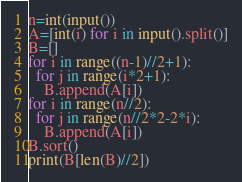Convert code to text. <code><loc_0><loc_0><loc_500><loc_500><_Python_>n=int(input())
A=[int(i) for i in input().split()]
B=[]
for i in range((n-1)//2+1):
  for j in range(i*2+1):
    B.append(A[i])
for i in range(n//2):
  for j in range(n//2*2-2*i):
    B.append(A[i])
B.sort()
print(B[len(B)//2])</code> 